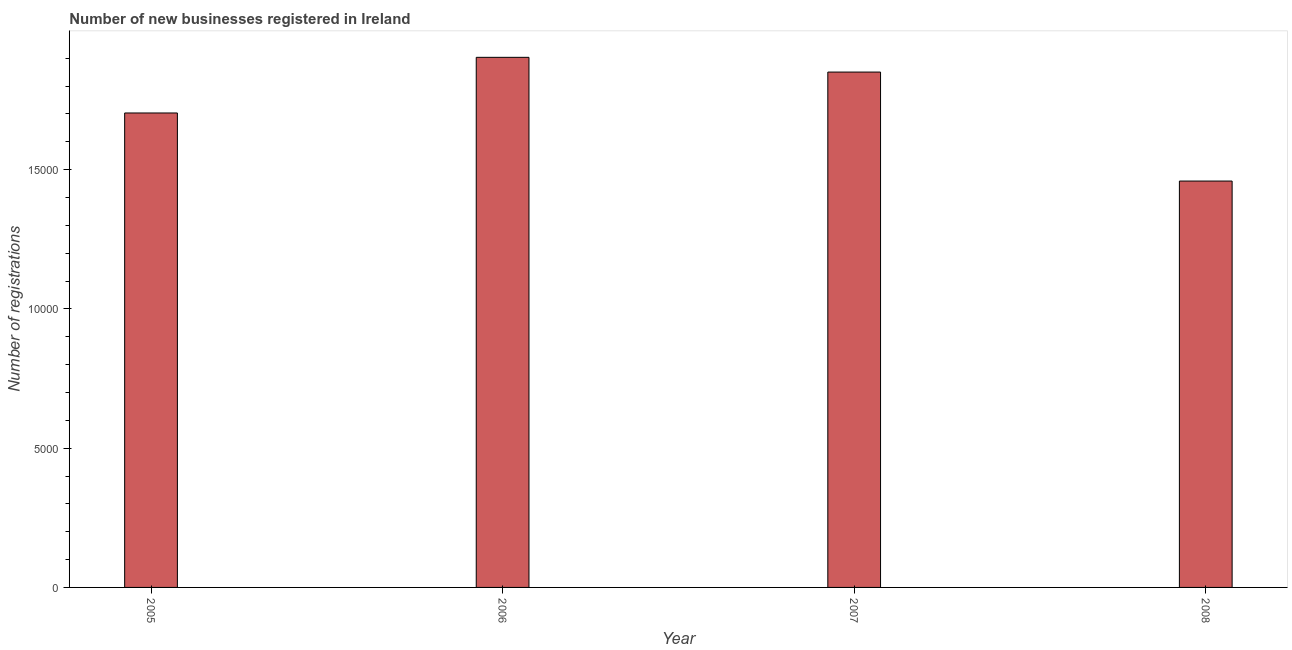Does the graph contain any zero values?
Your answer should be very brief. No. Does the graph contain grids?
Provide a succinct answer. No. What is the title of the graph?
Make the answer very short. Number of new businesses registered in Ireland. What is the label or title of the X-axis?
Give a very brief answer. Year. What is the label or title of the Y-axis?
Ensure brevity in your answer.  Number of registrations. What is the number of new business registrations in 2007?
Your answer should be very brief. 1.85e+04. Across all years, what is the maximum number of new business registrations?
Make the answer very short. 1.90e+04. Across all years, what is the minimum number of new business registrations?
Ensure brevity in your answer.  1.46e+04. In which year was the number of new business registrations maximum?
Provide a succinct answer. 2006. What is the sum of the number of new business registrations?
Provide a succinct answer. 6.92e+04. What is the difference between the number of new business registrations in 2007 and 2008?
Offer a terse response. 3913. What is the average number of new business registrations per year?
Offer a terse response. 1.73e+04. What is the median number of new business registrations?
Make the answer very short. 1.78e+04. Do a majority of the years between 2007 and 2005 (inclusive) have number of new business registrations greater than 18000 ?
Your response must be concise. Yes. What is the ratio of the number of new business registrations in 2005 to that in 2008?
Keep it short and to the point. 1.17. Is the number of new business registrations in 2006 less than that in 2008?
Your answer should be very brief. No. What is the difference between the highest and the second highest number of new business registrations?
Offer a terse response. 529. Is the sum of the number of new business registrations in 2006 and 2008 greater than the maximum number of new business registrations across all years?
Your answer should be compact. Yes. What is the difference between the highest and the lowest number of new business registrations?
Give a very brief answer. 4442. Are all the bars in the graph horizontal?
Your answer should be compact. No. What is the difference between two consecutive major ticks on the Y-axis?
Your answer should be very brief. 5000. What is the Number of registrations of 2005?
Your response must be concise. 1.70e+04. What is the Number of registrations of 2006?
Ensure brevity in your answer.  1.90e+04. What is the Number of registrations in 2007?
Keep it short and to the point. 1.85e+04. What is the Number of registrations of 2008?
Offer a terse response. 1.46e+04. What is the difference between the Number of registrations in 2005 and 2006?
Your answer should be very brief. -1998. What is the difference between the Number of registrations in 2005 and 2007?
Make the answer very short. -1469. What is the difference between the Number of registrations in 2005 and 2008?
Offer a terse response. 2444. What is the difference between the Number of registrations in 2006 and 2007?
Provide a succinct answer. 529. What is the difference between the Number of registrations in 2006 and 2008?
Provide a succinct answer. 4442. What is the difference between the Number of registrations in 2007 and 2008?
Your answer should be compact. 3913. What is the ratio of the Number of registrations in 2005 to that in 2006?
Provide a short and direct response. 0.9. What is the ratio of the Number of registrations in 2005 to that in 2007?
Provide a short and direct response. 0.92. What is the ratio of the Number of registrations in 2005 to that in 2008?
Ensure brevity in your answer.  1.17. What is the ratio of the Number of registrations in 2006 to that in 2008?
Offer a very short reply. 1.3. What is the ratio of the Number of registrations in 2007 to that in 2008?
Your answer should be compact. 1.27. 